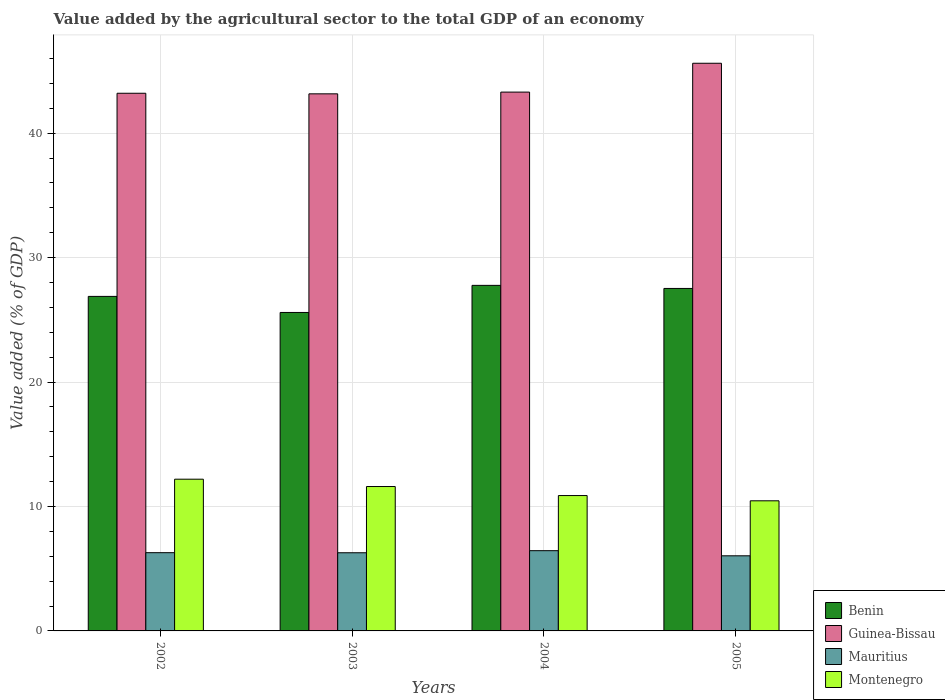How many different coloured bars are there?
Offer a terse response. 4. How many groups of bars are there?
Ensure brevity in your answer.  4. Are the number of bars per tick equal to the number of legend labels?
Provide a succinct answer. Yes. How many bars are there on the 3rd tick from the right?
Make the answer very short. 4. What is the label of the 2nd group of bars from the left?
Your answer should be compact. 2003. What is the value added by the agricultural sector to the total GDP in Montenegro in 2003?
Your answer should be compact. 11.61. Across all years, what is the maximum value added by the agricultural sector to the total GDP in Guinea-Bissau?
Provide a short and direct response. 45.62. Across all years, what is the minimum value added by the agricultural sector to the total GDP in Guinea-Bissau?
Your answer should be compact. 43.17. In which year was the value added by the agricultural sector to the total GDP in Montenegro maximum?
Provide a succinct answer. 2002. What is the total value added by the agricultural sector to the total GDP in Montenegro in the graph?
Provide a short and direct response. 45.14. What is the difference between the value added by the agricultural sector to the total GDP in Guinea-Bissau in 2002 and that in 2005?
Your response must be concise. -2.41. What is the difference between the value added by the agricultural sector to the total GDP in Mauritius in 2005 and the value added by the agricultural sector to the total GDP in Benin in 2002?
Offer a very short reply. -20.85. What is the average value added by the agricultural sector to the total GDP in Montenegro per year?
Your answer should be compact. 11.28. In the year 2004, what is the difference between the value added by the agricultural sector to the total GDP in Guinea-Bissau and value added by the agricultural sector to the total GDP in Benin?
Give a very brief answer. 15.53. What is the ratio of the value added by the agricultural sector to the total GDP in Guinea-Bissau in 2002 to that in 2004?
Give a very brief answer. 1. What is the difference between the highest and the second highest value added by the agricultural sector to the total GDP in Mauritius?
Keep it short and to the point. 0.16. What is the difference between the highest and the lowest value added by the agricultural sector to the total GDP in Guinea-Bissau?
Ensure brevity in your answer.  2.46. Is the sum of the value added by the agricultural sector to the total GDP in Guinea-Bissau in 2002 and 2003 greater than the maximum value added by the agricultural sector to the total GDP in Benin across all years?
Offer a very short reply. Yes. What does the 2nd bar from the left in 2002 represents?
Ensure brevity in your answer.  Guinea-Bissau. What does the 4th bar from the right in 2003 represents?
Keep it short and to the point. Benin. How many bars are there?
Provide a succinct answer. 16. How many years are there in the graph?
Your response must be concise. 4. Does the graph contain any zero values?
Provide a succinct answer. No. Does the graph contain grids?
Make the answer very short. Yes. What is the title of the graph?
Offer a very short reply. Value added by the agricultural sector to the total GDP of an economy. Does "Qatar" appear as one of the legend labels in the graph?
Offer a very short reply. No. What is the label or title of the Y-axis?
Your response must be concise. Value added (% of GDP). What is the Value added (% of GDP) in Benin in 2002?
Your answer should be very brief. 26.89. What is the Value added (% of GDP) of Guinea-Bissau in 2002?
Ensure brevity in your answer.  43.21. What is the Value added (% of GDP) of Mauritius in 2002?
Provide a short and direct response. 6.29. What is the Value added (% of GDP) in Montenegro in 2002?
Provide a short and direct response. 12.19. What is the Value added (% of GDP) of Benin in 2003?
Offer a terse response. 25.59. What is the Value added (% of GDP) of Guinea-Bissau in 2003?
Give a very brief answer. 43.17. What is the Value added (% of GDP) in Mauritius in 2003?
Keep it short and to the point. 6.28. What is the Value added (% of GDP) of Montenegro in 2003?
Your response must be concise. 11.61. What is the Value added (% of GDP) in Benin in 2004?
Give a very brief answer. 27.77. What is the Value added (% of GDP) in Guinea-Bissau in 2004?
Make the answer very short. 43.31. What is the Value added (% of GDP) in Mauritius in 2004?
Provide a short and direct response. 6.45. What is the Value added (% of GDP) of Montenegro in 2004?
Your answer should be compact. 10.88. What is the Value added (% of GDP) of Benin in 2005?
Your response must be concise. 27.53. What is the Value added (% of GDP) of Guinea-Bissau in 2005?
Ensure brevity in your answer.  45.62. What is the Value added (% of GDP) in Mauritius in 2005?
Offer a terse response. 6.04. What is the Value added (% of GDP) of Montenegro in 2005?
Your response must be concise. 10.46. Across all years, what is the maximum Value added (% of GDP) in Benin?
Make the answer very short. 27.77. Across all years, what is the maximum Value added (% of GDP) of Guinea-Bissau?
Give a very brief answer. 45.62. Across all years, what is the maximum Value added (% of GDP) of Mauritius?
Your response must be concise. 6.45. Across all years, what is the maximum Value added (% of GDP) in Montenegro?
Provide a succinct answer. 12.19. Across all years, what is the minimum Value added (% of GDP) of Benin?
Offer a very short reply. 25.59. Across all years, what is the minimum Value added (% of GDP) of Guinea-Bissau?
Make the answer very short. 43.17. Across all years, what is the minimum Value added (% of GDP) of Mauritius?
Offer a terse response. 6.04. Across all years, what is the minimum Value added (% of GDP) in Montenegro?
Provide a succinct answer. 10.46. What is the total Value added (% of GDP) of Benin in the graph?
Keep it short and to the point. 107.78. What is the total Value added (% of GDP) of Guinea-Bissau in the graph?
Give a very brief answer. 175.31. What is the total Value added (% of GDP) of Mauritius in the graph?
Your answer should be very brief. 25.06. What is the total Value added (% of GDP) of Montenegro in the graph?
Provide a short and direct response. 45.14. What is the difference between the Value added (% of GDP) in Benin in 2002 and that in 2003?
Your answer should be very brief. 1.29. What is the difference between the Value added (% of GDP) of Guinea-Bissau in 2002 and that in 2003?
Your response must be concise. 0.05. What is the difference between the Value added (% of GDP) in Mauritius in 2002 and that in 2003?
Ensure brevity in your answer.  0.01. What is the difference between the Value added (% of GDP) of Montenegro in 2002 and that in 2003?
Provide a short and direct response. 0.59. What is the difference between the Value added (% of GDP) in Benin in 2002 and that in 2004?
Provide a short and direct response. -0.89. What is the difference between the Value added (% of GDP) in Guinea-Bissau in 2002 and that in 2004?
Provide a succinct answer. -0.09. What is the difference between the Value added (% of GDP) of Mauritius in 2002 and that in 2004?
Keep it short and to the point. -0.16. What is the difference between the Value added (% of GDP) in Montenegro in 2002 and that in 2004?
Give a very brief answer. 1.31. What is the difference between the Value added (% of GDP) in Benin in 2002 and that in 2005?
Make the answer very short. -0.64. What is the difference between the Value added (% of GDP) of Guinea-Bissau in 2002 and that in 2005?
Offer a very short reply. -2.41. What is the difference between the Value added (% of GDP) in Mauritius in 2002 and that in 2005?
Your answer should be very brief. 0.25. What is the difference between the Value added (% of GDP) of Montenegro in 2002 and that in 2005?
Ensure brevity in your answer.  1.74. What is the difference between the Value added (% of GDP) in Benin in 2003 and that in 2004?
Your answer should be very brief. -2.18. What is the difference between the Value added (% of GDP) of Guinea-Bissau in 2003 and that in 2004?
Offer a very short reply. -0.14. What is the difference between the Value added (% of GDP) in Mauritius in 2003 and that in 2004?
Ensure brevity in your answer.  -0.17. What is the difference between the Value added (% of GDP) in Montenegro in 2003 and that in 2004?
Give a very brief answer. 0.73. What is the difference between the Value added (% of GDP) in Benin in 2003 and that in 2005?
Provide a short and direct response. -1.93. What is the difference between the Value added (% of GDP) in Guinea-Bissau in 2003 and that in 2005?
Your answer should be very brief. -2.46. What is the difference between the Value added (% of GDP) of Mauritius in 2003 and that in 2005?
Give a very brief answer. 0.24. What is the difference between the Value added (% of GDP) in Montenegro in 2003 and that in 2005?
Make the answer very short. 1.15. What is the difference between the Value added (% of GDP) in Benin in 2004 and that in 2005?
Ensure brevity in your answer.  0.25. What is the difference between the Value added (% of GDP) in Guinea-Bissau in 2004 and that in 2005?
Ensure brevity in your answer.  -2.32. What is the difference between the Value added (% of GDP) of Mauritius in 2004 and that in 2005?
Your answer should be very brief. 0.41. What is the difference between the Value added (% of GDP) of Montenegro in 2004 and that in 2005?
Offer a very short reply. 0.42. What is the difference between the Value added (% of GDP) of Benin in 2002 and the Value added (% of GDP) of Guinea-Bissau in 2003?
Ensure brevity in your answer.  -16.28. What is the difference between the Value added (% of GDP) of Benin in 2002 and the Value added (% of GDP) of Mauritius in 2003?
Offer a terse response. 20.6. What is the difference between the Value added (% of GDP) of Benin in 2002 and the Value added (% of GDP) of Montenegro in 2003?
Ensure brevity in your answer.  15.28. What is the difference between the Value added (% of GDP) of Guinea-Bissau in 2002 and the Value added (% of GDP) of Mauritius in 2003?
Give a very brief answer. 36.93. What is the difference between the Value added (% of GDP) of Guinea-Bissau in 2002 and the Value added (% of GDP) of Montenegro in 2003?
Keep it short and to the point. 31.61. What is the difference between the Value added (% of GDP) in Mauritius in 2002 and the Value added (% of GDP) in Montenegro in 2003?
Your answer should be compact. -5.32. What is the difference between the Value added (% of GDP) of Benin in 2002 and the Value added (% of GDP) of Guinea-Bissau in 2004?
Make the answer very short. -16.42. What is the difference between the Value added (% of GDP) in Benin in 2002 and the Value added (% of GDP) in Mauritius in 2004?
Provide a short and direct response. 20.44. What is the difference between the Value added (% of GDP) in Benin in 2002 and the Value added (% of GDP) in Montenegro in 2004?
Ensure brevity in your answer.  16.01. What is the difference between the Value added (% of GDP) of Guinea-Bissau in 2002 and the Value added (% of GDP) of Mauritius in 2004?
Give a very brief answer. 36.76. What is the difference between the Value added (% of GDP) in Guinea-Bissau in 2002 and the Value added (% of GDP) in Montenegro in 2004?
Offer a terse response. 32.33. What is the difference between the Value added (% of GDP) in Mauritius in 2002 and the Value added (% of GDP) in Montenegro in 2004?
Your response must be concise. -4.59. What is the difference between the Value added (% of GDP) of Benin in 2002 and the Value added (% of GDP) of Guinea-Bissau in 2005?
Give a very brief answer. -18.74. What is the difference between the Value added (% of GDP) in Benin in 2002 and the Value added (% of GDP) in Mauritius in 2005?
Provide a succinct answer. 20.85. What is the difference between the Value added (% of GDP) of Benin in 2002 and the Value added (% of GDP) of Montenegro in 2005?
Offer a terse response. 16.43. What is the difference between the Value added (% of GDP) of Guinea-Bissau in 2002 and the Value added (% of GDP) of Mauritius in 2005?
Offer a very short reply. 37.18. What is the difference between the Value added (% of GDP) in Guinea-Bissau in 2002 and the Value added (% of GDP) in Montenegro in 2005?
Provide a short and direct response. 32.76. What is the difference between the Value added (% of GDP) in Mauritius in 2002 and the Value added (% of GDP) in Montenegro in 2005?
Provide a succinct answer. -4.17. What is the difference between the Value added (% of GDP) in Benin in 2003 and the Value added (% of GDP) in Guinea-Bissau in 2004?
Your answer should be very brief. -17.71. What is the difference between the Value added (% of GDP) in Benin in 2003 and the Value added (% of GDP) in Mauritius in 2004?
Make the answer very short. 19.15. What is the difference between the Value added (% of GDP) in Benin in 2003 and the Value added (% of GDP) in Montenegro in 2004?
Provide a succinct answer. 14.71. What is the difference between the Value added (% of GDP) of Guinea-Bissau in 2003 and the Value added (% of GDP) of Mauritius in 2004?
Offer a very short reply. 36.72. What is the difference between the Value added (% of GDP) in Guinea-Bissau in 2003 and the Value added (% of GDP) in Montenegro in 2004?
Provide a short and direct response. 32.29. What is the difference between the Value added (% of GDP) in Mauritius in 2003 and the Value added (% of GDP) in Montenegro in 2004?
Your response must be concise. -4.6. What is the difference between the Value added (% of GDP) in Benin in 2003 and the Value added (% of GDP) in Guinea-Bissau in 2005?
Your answer should be compact. -20.03. What is the difference between the Value added (% of GDP) of Benin in 2003 and the Value added (% of GDP) of Mauritius in 2005?
Your answer should be compact. 19.56. What is the difference between the Value added (% of GDP) in Benin in 2003 and the Value added (% of GDP) in Montenegro in 2005?
Your answer should be compact. 15.14. What is the difference between the Value added (% of GDP) of Guinea-Bissau in 2003 and the Value added (% of GDP) of Mauritius in 2005?
Make the answer very short. 37.13. What is the difference between the Value added (% of GDP) in Guinea-Bissau in 2003 and the Value added (% of GDP) in Montenegro in 2005?
Give a very brief answer. 32.71. What is the difference between the Value added (% of GDP) in Mauritius in 2003 and the Value added (% of GDP) in Montenegro in 2005?
Offer a very short reply. -4.18. What is the difference between the Value added (% of GDP) in Benin in 2004 and the Value added (% of GDP) in Guinea-Bissau in 2005?
Offer a terse response. -17.85. What is the difference between the Value added (% of GDP) of Benin in 2004 and the Value added (% of GDP) of Mauritius in 2005?
Your response must be concise. 21.74. What is the difference between the Value added (% of GDP) of Benin in 2004 and the Value added (% of GDP) of Montenegro in 2005?
Offer a very short reply. 17.32. What is the difference between the Value added (% of GDP) of Guinea-Bissau in 2004 and the Value added (% of GDP) of Mauritius in 2005?
Offer a terse response. 37.27. What is the difference between the Value added (% of GDP) in Guinea-Bissau in 2004 and the Value added (% of GDP) in Montenegro in 2005?
Ensure brevity in your answer.  32.85. What is the difference between the Value added (% of GDP) of Mauritius in 2004 and the Value added (% of GDP) of Montenegro in 2005?
Offer a very short reply. -4.01. What is the average Value added (% of GDP) in Benin per year?
Your answer should be compact. 26.94. What is the average Value added (% of GDP) in Guinea-Bissau per year?
Provide a succinct answer. 43.83. What is the average Value added (% of GDP) of Mauritius per year?
Your answer should be compact. 6.26. What is the average Value added (% of GDP) of Montenegro per year?
Ensure brevity in your answer.  11.28. In the year 2002, what is the difference between the Value added (% of GDP) in Benin and Value added (% of GDP) in Guinea-Bissau?
Provide a short and direct response. -16.33. In the year 2002, what is the difference between the Value added (% of GDP) in Benin and Value added (% of GDP) in Mauritius?
Ensure brevity in your answer.  20.6. In the year 2002, what is the difference between the Value added (% of GDP) of Benin and Value added (% of GDP) of Montenegro?
Make the answer very short. 14.69. In the year 2002, what is the difference between the Value added (% of GDP) in Guinea-Bissau and Value added (% of GDP) in Mauritius?
Your answer should be very brief. 36.92. In the year 2002, what is the difference between the Value added (% of GDP) in Guinea-Bissau and Value added (% of GDP) in Montenegro?
Keep it short and to the point. 31.02. In the year 2002, what is the difference between the Value added (% of GDP) of Mauritius and Value added (% of GDP) of Montenegro?
Your answer should be compact. -5.91. In the year 2003, what is the difference between the Value added (% of GDP) in Benin and Value added (% of GDP) in Guinea-Bissau?
Your answer should be very brief. -17.57. In the year 2003, what is the difference between the Value added (% of GDP) in Benin and Value added (% of GDP) in Mauritius?
Ensure brevity in your answer.  19.31. In the year 2003, what is the difference between the Value added (% of GDP) of Benin and Value added (% of GDP) of Montenegro?
Provide a succinct answer. 13.99. In the year 2003, what is the difference between the Value added (% of GDP) in Guinea-Bissau and Value added (% of GDP) in Mauritius?
Make the answer very short. 36.88. In the year 2003, what is the difference between the Value added (% of GDP) in Guinea-Bissau and Value added (% of GDP) in Montenegro?
Offer a very short reply. 31.56. In the year 2003, what is the difference between the Value added (% of GDP) of Mauritius and Value added (% of GDP) of Montenegro?
Provide a short and direct response. -5.32. In the year 2004, what is the difference between the Value added (% of GDP) of Benin and Value added (% of GDP) of Guinea-Bissau?
Keep it short and to the point. -15.53. In the year 2004, what is the difference between the Value added (% of GDP) of Benin and Value added (% of GDP) of Mauritius?
Your answer should be compact. 21.32. In the year 2004, what is the difference between the Value added (% of GDP) in Benin and Value added (% of GDP) in Montenegro?
Give a very brief answer. 16.89. In the year 2004, what is the difference between the Value added (% of GDP) of Guinea-Bissau and Value added (% of GDP) of Mauritius?
Give a very brief answer. 36.86. In the year 2004, what is the difference between the Value added (% of GDP) of Guinea-Bissau and Value added (% of GDP) of Montenegro?
Provide a succinct answer. 32.43. In the year 2004, what is the difference between the Value added (% of GDP) in Mauritius and Value added (% of GDP) in Montenegro?
Ensure brevity in your answer.  -4.43. In the year 2005, what is the difference between the Value added (% of GDP) of Benin and Value added (% of GDP) of Guinea-Bissau?
Give a very brief answer. -18.1. In the year 2005, what is the difference between the Value added (% of GDP) of Benin and Value added (% of GDP) of Mauritius?
Offer a very short reply. 21.49. In the year 2005, what is the difference between the Value added (% of GDP) of Benin and Value added (% of GDP) of Montenegro?
Your answer should be very brief. 17.07. In the year 2005, what is the difference between the Value added (% of GDP) of Guinea-Bissau and Value added (% of GDP) of Mauritius?
Provide a short and direct response. 39.59. In the year 2005, what is the difference between the Value added (% of GDP) of Guinea-Bissau and Value added (% of GDP) of Montenegro?
Offer a terse response. 35.17. In the year 2005, what is the difference between the Value added (% of GDP) of Mauritius and Value added (% of GDP) of Montenegro?
Your answer should be very brief. -4.42. What is the ratio of the Value added (% of GDP) in Benin in 2002 to that in 2003?
Make the answer very short. 1.05. What is the ratio of the Value added (% of GDP) of Guinea-Bissau in 2002 to that in 2003?
Give a very brief answer. 1. What is the ratio of the Value added (% of GDP) in Montenegro in 2002 to that in 2003?
Offer a very short reply. 1.05. What is the ratio of the Value added (% of GDP) in Benin in 2002 to that in 2004?
Make the answer very short. 0.97. What is the ratio of the Value added (% of GDP) of Guinea-Bissau in 2002 to that in 2004?
Make the answer very short. 1. What is the ratio of the Value added (% of GDP) in Mauritius in 2002 to that in 2004?
Your response must be concise. 0.98. What is the ratio of the Value added (% of GDP) in Montenegro in 2002 to that in 2004?
Provide a short and direct response. 1.12. What is the ratio of the Value added (% of GDP) of Benin in 2002 to that in 2005?
Provide a short and direct response. 0.98. What is the ratio of the Value added (% of GDP) in Guinea-Bissau in 2002 to that in 2005?
Provide a short and direct response. 0.95. What is the ratio of the Value added (% of GDP) of Mauritius in 2002 to that in 2005?
Provide a short and direct response. 1.04. What is the ratio of the Value added (% of GDP) of Montenegro in 2002 to that in 2005?
Your response must be concise. 1.17. What is the ratio of the Value added (% of GDP) of Benin in 2003 to that in 2004?
Provide a short and direct response. 0.92. What is the ratio of the Value added (% of GDP) in Mauritius in 2003 to that in 2004?
Give a very brief answer. 0.97. What is the ratio of the Value added (% of GDP) of Montenegro in 2003 to that in 2004?
Offer a terse response. 1.07. What is the ratio of the Value added (% of GDP) of Benin in 2003 to that in 2005?
Keep it short and to the point. 0.93. What is the ratio of the Value added (% of GDP) of Guinea-Bissau in 2003 to that in 2005?
Make the answer very short. 0.95. What is the ratio of the Value added (% of GDP) of Mauritius in 2003 to that in 2005?
Offer a terse response. 1.04. What is the ratio of the Value added (% of GDP) of Montenegro in 2003 to that in 2005?
Your response must be concise. 1.11. What is the ratio of the Value added (% of GDP) in Benin in 2004 to that in 2005?
Ensure brevity in your answer.  1.01. What is the ratio of the Value added (% of GDP) of Guinea-Bissau in 2004 to that in 2005?
Offer a terse response. 0.95. What is the ratio of the Value added (% of GDP) in Mauritius in 2004 to that in 2005?
Give a very brief answer. 1.07. What is the ratio of the Value added (% of GDP) in Montenegro in 2004 to that in 2005?
Your response must be concise. 1.04. What is the difference between the highest and the second highest Value added (% of GDP) of Benin?
Make the answer very short. 0.25. What is the difference between the highest and the second highest Value added (% of GDP) in Guinea-Bissau?
Your answer should be very brief. 2.32. What is the difference between the highest and the second highest Value added (% of GDP) in Mauritius?
Ensure brevity in your answer.  0.16. What is the difference between the highest and the second highest Value added (% of GDP) of Montenegro?
Ensure brevity in your answer.  0.59. What is the difference between the highest and the lowest Value added (% of GDP) in Benin?
Keep it short and to the point. 2.18. What is the difference between the highest and the lowest Value added (% of GDP) of Guinea-Bissau?
Your answer should be very brief. 2.46. What is the difference between the highest and the lowest Value added (% of GDP) in Mauritius?
Give a very brief answer. 0.41. What is the difference between the highest and the lowest Value added (% of GDP) of Montenegro?
Make the answer very short. 1.74. 